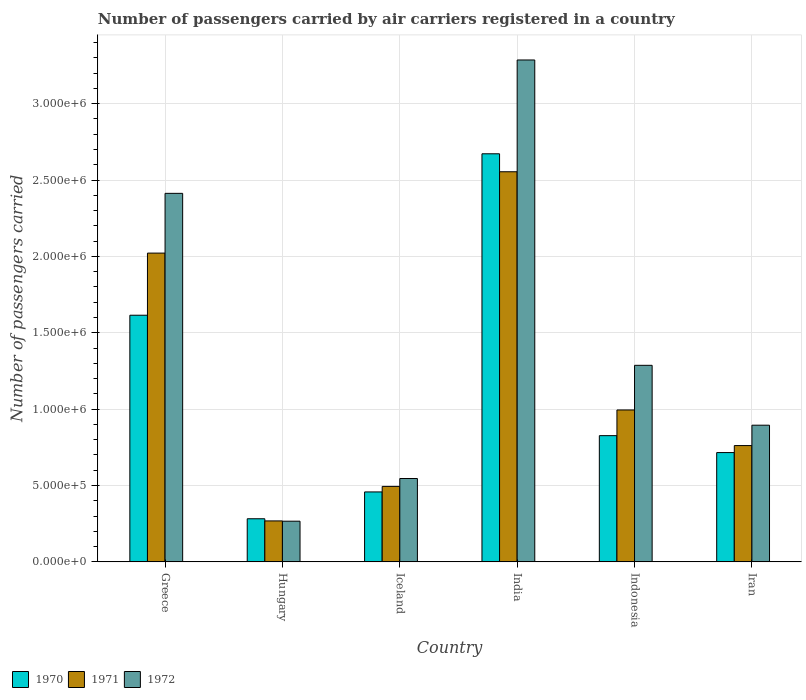How many different coloured bars are there?
Your answer should be compact. 3. How many groups of bars are there?
Keep it short and to the point. 6. Are the number of bars on each tick of the X-axis equal?
Offer a very short reply. Yes. What is the number of passengers carried by air carriers in 1971 in Hungary?
Give a very brief answer. 2.68e+05. Across all countries, what is the maximum number of passengers carried by air carriers in 1970?
Your answer should be very brief. 2.67e+06. Across all countries, what is the minimum number of passengers carried by air carriers in 1970?
Provide a short and direct response. 2.82e+05. In which country was the number of passengers carried by air carriers in 1971 minimum?
Your answer should be very brief. Hungary. What is the total number of passengers carried by air carriers in 1970 in the graph?
Provide a short and direct response. 6.57e+06. What is the difference between the number of passengers carried by air carriers in 1970 in Iceland and that in Indonesia?
Make the answer very short. -3.68e+05. What is the difference between the number of passengers carried by air carriers in 1971 in Greece and the number of passengers carried by air carriers in 1970 in Iran?
Provide a succinct answer. 1.31e+06. What is the average number of passengers carried by air carriers in 1971 per country?
Your answer should be compact. 1.18e+06. What is the difference between the number of passengers carried by air carriers of/in 1970 and number of passengers carried by air carriers of/in 1972 in India?
Your answer should be compact. -6.14e+05. In how many countries, is the number of passengers carried by air carriers in 1972 greater than 400000?
Provide a short and direct response. 5. What is the ratio of the number of passengers carried by air carriers in 1971 in Hungary to that in Iran?
Keep it short and to the point. 0.35. What is the difference between the highest and the second highest number of passengers carried by air carriers in 1972?
Give a very brief answer. 8.73e+05. What is the difference between the highest and the lowest number of passengers carried by air carriers in 1970?
Provide a succinct answer. 2.39e+06. What does the 2nd bar from the left in Iceland represents?
Offer a terse response. 1971. What does the 3rd bar from the right in Hungary represents?
Provide a succinct answer. 1970. Is it the case that in every country, the sum of the number of passengers carried by air carriers in 1972 and number of passengers carried by air carriers in 1971 is greater than the number of passengers carried by air carriers in 1970?
Your answer should be compact. Yes. Are the values on the major ticks of Y-axis written in scientific E-notation?
Provide a short and direct response. Yes. Does the graph contain any zero values?
Your answer should be compact. No. How many legend labels are there?
Provide a short and direct response. 3. What is the title of the graph?
Offer a very short reply. Number of passengers carried by air carriers registered in a country. Does "1964" appear as one of the legend labels in the graph?
Your answer should be compact. No. What is the label or title of the Y-axis?
Your response must be concise. Number of passengers carried. What is the Number of passengers carried in 1970 in Greece?
Provide a succinct answer. 1.61e+06. What is the Number of passengers carried of 1971 in Greece?
Your answer should be compact. 2.02e+06. What is the Number of passengers carried of 1972 in Greece?
Offer a very short reply. 2.41e+06. What is the Number of passengers carried in 1970 in Hungary?
Give a very brief answer. 2.82e+05. What is the Number of passengers carried of 1971 in Hungary?
Your answer should be compact. 2.68e+05. What is the Number of passengers carried in 1972 in Hungary?
Make the answer very short. 2.66e+05. What is the Number of passengers carried in 1970 in Iceland?
Offer a terse response. 4.58e+05. What is the Number of passengers carried in 1971 in Iceland?
Offer a terse response. 4.94e+05. What is the Number of passengers carried of 1972 in Iceland?
Ensure brevity in your answer.  5.46e+05. What is the Number of passengers carried in 1970 in India?
Your answer should be compact. 2.67e+06. What is the Number of passengers carried in 1971 in India?
Your answer should be very brief. 2.55e+06. What is the Number of passengers carried of 1972 in India?
Offer a terse response. 3.29e+06. What is the Number of passengers carried of 1970 in Indonesia?
Give a very brief answer. 8.26e+05. What is the Number of passengers carried of 1971 in Indonesia?
Ensure brevity in your answer.  9.94e+05. What is the Number of passengers carried in 1972 in Indonesia?
Keep it short and to the point. 1.29e+06. What is the Number of passengers carried in 1970 in Iran?
Keep it short and to the point. 7.16e+05. What is the Number of passengers carried of 1971 in Iran?
Offer a very short reply. 7.61e+05. What is the Number of passengers carried in 1972 in Iran?
Offer a terse response. 8.95e+05. Across all countries, what is the maximum Number of passengers carried in 1970?
Your answer should be compact. 2.67e+06. Across all countries, what is the maximum Number of passengers carried of 1971?
Ensure brevity in your answer.  2.55e+06. Across all countries, what is the maximum Number of passengers carried of 1972?
Your answer should be very brief. 3.29e+06. Across all countries, what is the minimum Number of passengers carried of 1970?
Give a very brief answer. 2.82e+05. Across all countries, what is the minimum Number of passengers carried in 1971?
Provide a succinct answer. 2.68e+05. Across all countries, what is the minimum Number of passengers carried of 1972?
Your response must be concise. 2.66e+05. What is the total Number of passengers carried in 1970 in the graph?
Offer a terse response. 6.57e+06. What is the total Number of passengers carried of 1971 in the graph?
Make the answer very short. 7.09e+06. What is the total Number of passengers carried of 1972 in the graph?
Provide a short and direct response. 8.69e+06. What is the difference between the Number of passengers carried in 1970 in Greece and that in Hungary?
Offer a very short reply. 1.33e+06. What is the difference between the Number of passengers carried in 1971 in Greece and that in Hungary?
Make the answer very short. 1.75e+06. What is the difference between the Number of passengers carried of 1972 in Greece and that in Hungary?
Give a very brief answer. 2.15e+06. What is the difference between the Number of passengers carried of 1970 in Greece and that in Iceland?
Provide a short and direct response. 1.16e+06. What is the difference between the Number of passengers carried of 1971 in Greece and that in Iceland?
Provide a short and direct response. 1.53e+06. What is the difference between the Number of passengers carried in 1972 in Greece and that in Iceland?
Make the answer very short. 1.87e+06. What is the difference between the Number of passengers carried in 1970 in Greece and that in India?
Ensure brevity in your answer.  -1.06e+06. What is the difference between the Number of passengers carried in 1971 in Greece and that in India?
Ensure brevity in your answer.  -5.33e+05. What is the difference between the Number of passengers carried in 1972 in Greece and that in India?
Give a very brief answer. -8.73e+05. What is the difference between the Number of passengers carried in 1970 in Greece and that in Indonesia?
Your response must be concise. 7.88e+05. What is the difference between the Number of passengers carried in 1971 in Greece and that in Indonesia?
Make the answer very short. 1.03e+06. What is the difference between the Number of passengers carried of 1972 in Greece and that in Indonesia?
Provide a succinct answer. 1.13e+06. What is the difference between the Number of passengers carried of 1970 in Greece and that in Iran?
Offer a terse response. 8.99e+05. What is the difference between the Number of passengers carried of 1971 in Greece and that in Iran?
Provide a succinct answer. 1.26e+06. What is the difference between the Number of passengers carried in 1972 in Greece and that in Iran?
Your response must be concise. 1.52e+06. What is the difference between the Number of passengers carried of 1970 in Hungary and that in Iceland?
Your answer should be very brief. -1.76e+05. What is the difference between the Number of passengers carried of 1971 in Hungary and that in Iceland?
Your answer should be very brief. -2.26e+05. What is the difference between the Number of passengers carried in 1972 in Hungary and that in Iceland?
Your response must be concise. -2.80e+05. What is the difference between the Number of passengers carried in 1970 in Hungary and that in India?
Offer a terse response. -2.39e+06. What is the difference between the Number of passengers carried in 1971 in Hungary and that in India?
Give a very brief answer. -2.29e+06. What is the difference between the Number of passengers carried of 1972 in Hungary and that in India?
Make the answer very short. -3.02e+06. What is the difference between the Number of passengers carried of 1970 in Hungary and that in Indonesia?
Ensure brevity in your answer.  -5.44e+05. What is the difference between the Number of passengers carried of 1971 in Hungary and that in Indonesia?
Provide a succinct answer. -7.26e+05. What is the difference between the Number of passengers carried in 1972 in Hungary and that in Indonesia?
Keep it short and to the point. -1.02e+06. What is the difference between the Number of passengers carried in 1970 in Hungary and that in Iran?
Offer a very short reply. -4.33e+05. What is the difference between the Number of passengers carried of 1971 in Hungary and that in Iran?
Provide a succinct answer. -4.93e+05. What is the difference between the Number of passengers carried of 1972 in Hungary and that in Iran?
Provide a short and direct response. -6.28e+05. What is the difference between the Number of passengers carried in 1970 in Iceland and that in India?
Make the answer very short. -2.21e+06. What is the difference between the Number of passengers carried in 1971 in Iceland and that in India?
Offer a very short reply. -2.06e+06. What is the difference between the Number of passengers carried of 1972 in Iceland and that in India?
Your response must be concise. -2.74e+06. What is the difference between the Number of passengers carried in 1970 in Iceland and that in Indonesia?
Make the answer very short. -3.68e+05. What is the difference between the Number of passengers carried of 1971 in Iceland and that in Indonesia?
Provide a short and direct response. -5.00e+05. What is the difference between the Number of passengers carried in 1972 in Iceland and that in Indonesia?
Your answer should be very brief. -7.41e+05. What is the difference between the Number of passengers carried in 1970 in Iceland and that in Iran?
Ensure brevity in your answer.  -2.58e+05. What is the difference between the Number of passengers carried of 1971 in Iceland and that in Iran?
Ensure brevity in your answer.  -2.67e+05. What is the difference between the Number of passengers carried of 1972 in Iceland and that in Iran?
Provide a short and direct response. -3.49e+05. What is the difference between the Number of passengers carried in 1970 in India and that in Indonesia?
Your answer should be very brief. 1.85e+06. What is the difference between the Number of passengers carried of 1971 in India and that in Indonesia?
Offer a terse response. 1.56e+06. What is the difference between the Number of passengers carried in 1972 in India and that in Indonesia?
Your response must be concise. 2.00e+06. What is the difference between the Number of passengers carried in 1970 in India and that in Iran?
Your answer should be compact. 1.96e+06. What is the difference between the Number of passengers carried of 1971 in India and that in Iran?
Your answer should be very brief. 1.79e+06. What is the difference between the Number of passengers carried in 1972 in India and that in Iran?
Keep it short and to the point. 2.39e+06. What is the difference between the Number of passengers carried in 1970 in Indonesia and that in Iran?
Offer a terse response. 1.11e+05. What is the difference between the Number of passengers carried in 1971 in Indonesia and that in Iran?
Your response must be concise. 2.33e+05. What is the difference between the Number of passengers carried in 1972 in Indonesia and that in Iran?
Keep it short and to the point. 3.92e+05. What is the difference between the Number of passengers carried in 1970 in Greece and the Number of passengers carried in 1971 in Hungary?
Make the answer very short. 1.35e+06. What is the difference between the Number of passengers carried of 1970 in Greece and the Number of passengers carried of 1972 in Hungary?
Your response must be concise. 1.35e+06. What is the difference between the Number of passengers carried of 1971 in Greece and the Number of passengers carried of 1972 in Hungary?
Ensure brevity in your answer.  1.76e+06. What is the difference between the Number of passengers carried in 1970 in Greece and the Number of passengers carried in 1971 in Iceland?
Provide a short and direct response. 1.12e+06. What is the difference between the Number of passengers carried of 1970 in Greece and the Number of passengers carried of 1972 in Iceland?
Your answer should be compact. 1.07e+06. What is the difference between the Number of passengers carried of 1971 in Greece and the Number of passengers carried of 1972 in Iceland?
Offer a very short reply. 1.48e+06. What is the difference between the Number of passengers carried of 1970 in Greece and the Number of passengers carried of 1971 in India?
Offer a terse response. -9.39e+05. What is the difference between the Number of passengers carried in 1970 in Greece and the Number of passengers carried in 1972 in India?
Your response must be concise. -1.67e+06. What is the difference between the Number of passengers carried in 1971 in Greece and the Number of passengers carried in 1972 in India?
Make the answer very short. -1.26e+06. What is the difference between the Number of passengers carried of 1970 in Greece and the Number of passengers carried of 1971 in Indonesia?
Keep it short and to the point. 6.20e+05. What is the difference between the Number of passengers carried of 1970 in Greece and the Number of passengers carried of 1972 in Indonesia?
Keep it short and to the point. 3.28e+05. What is the difference between the Number of passengers carried in 1971 in Greece and the Number of passengers carried in 1972 in Indonesia?
Provide a succinct answer. 7.35e+05. What is the difference between the Number of passengers carried in 1970 in Greece and the Number of passengers carried in 1971 in Iran?
Keep it short and to the point. 8.53e+05. What is the difference between the Number of passengers carried of 1970 in Greece and the Number of passengers carried of 1972 in Iran?
Keep it short and to the point. 7.20e+05. What is the difference between the Number of passengers carried of 1971 in Greece and the Number of passengers carried of 1972 in Iran?
Provide a short and direct response. 1.13e+06. What is the difference between the Number of passengers carried in 1970 in Hungary and the Number of passengers carried in 1971 in Iceland?
Provide a short and direct response. -2.12e+05. What is the difference between the Number of passengers carried in 1970 in Hungary and the Number of passengers carried in 1972 in Iceland?
Your answer should be very brief. -2.64e+05. What is the difference between the Number of passengers carried of 1971 in Hungary and the Number of passengers carried of 1972 in Iceland?
Provide a short and direct response. -2.78e+05. What is the difference between the Number of passengers carried in 1970 in Hungary and the Number of passengers carried in 1971 in India?
Make the answer very short. -2.27e+06. What is the difference between the Number of passengers carried of 1970 in Hungary and the Number of passengers carried of 1972 in India?
Keep it short and to the point. -3.00e+06. What is the difference between the Number of passengers carried in 1971 in Hungary and the Number of passengers carried in 1972 in India?
Ensure brevity in your answer.  -3.02e+06. What is the difference between the Number of passengers carried of 1970 in Hungary and the Number of passengers carried of 1971 in Indonesia?
Provide a succinct answer. -7.12e+05. What is the difference between the Number of passengers carried in 1970 in Hungary and the Number of passengers carried in 1972 in Indonesia?
Offer a terse response. -1.00e+06. What is the difference between the Number of passengers carried in 1971 in Hungary and the Number of passengers carried in 1972 in Indonesia?
Make the answer very short. -1.02e+06. What is the difference between the Number of passengers carried of 1970 in Hungary and the Number of passengers carried of 1971 in Iran?
Your response must be concise. -4.79e+05. What is the difference between the Number of passengers carried of 1970 in Hungary and the Number of passengers carried of 1972 in Iran?
Your answer should be very brief. -6.12e+05. What is the difference between the Number of passengers carried of 1971 in Hungary and the Number of passengers carried of 1972 in Iran?
Keep it short and to the point. -6.27e+05. What is the difference between the Number of passengers carried in 1970 in Iceland and the Number of passengers carried in 1971 in India?
Provide a succinct answer. -2.10e+06. What is the difference between the Number of passengers carried in 1970 in Iceland and the Number of passengers carried in 1972 in India?
Offer a terse response. -2.83e+06. What is the difference between the Number of passengers carried in 1971 in Iceland and the Number of passengers carried in 1972 in India?
Your answer should be compact. -2.79e+06. What is the difference between the Number of passengers carried in 1970 in Iceland and the Number of passengers carried in 1971 in Indonesia?
Your answer should be very brief. -5.37e+05. What is the difference between the Number of passengers carried of 1970 in Iceland and the Number of passengers carried of 1972 in Indonesia?
Provide a short and direct response. -8.29e+05. What is the difference between the Number of passengers carried of 1971 in Iceland and the Number of passengers carried of 1972 in Indonesia?
Provide a succinct answer. -7.93e+05. What is the difference between the Number of passengers carried in 1970 in Iceland and the Number of passengers carried in 1971 in Iran?
Offer a very short reply. -3.04e+05. What is the difference between the Number of passengers carried of 1970 in Iceland and the Number of passengers carried of 1972 in Iran?
Keep it short and to the point. -4.37e+05. What is the difference between the Number of passengers carried in 1971 in Iceland and the Number of passengers carried in 1972 in Iran?
Your answer should be compact. -4.01e+05. What is the difference between the Number of passengers carried in 1970 in India and the Number of passengers carried in 1971 in Indonesia?
Make the answer very short. 1.68e+06. What is the difference between the Number of passengers carried of 1970 in India and the Number of passengers carried of 1972 in Indonesia?
Your answer should be compact. 1.38e+06. What is the difference between the Number of passengers carried of 1971 in India and the Number of passengers carried of 1972 in Indonesia?
Offer a very short reply. 1.27e+06. What is the difference between the Number of passengers carried of 1970 in India and the Number of passengers carried of 1971 in Iran?
Your response must be concise. 1.91e+06. What is the difference between the Number of passengers carried in 1970 in India and the Number of passengers carried in 1972 in Iran?
Your answer should be very brief. 1.78e+06. What is the difference between the Number of passengers carried in 1971 in India and the Number of passengers carried in 1972 in Iran?
Provide a succinct answer. 1.66e+06. What is the difference between the Number of passengers carried of 1970 in Indonesia and the Number of passengers carried of 1971 in Iran?
Keep it short and to the point. 6.50e+04. What is the difference between the Number of passengers carried of 1970 in Indonesia and the Number of passengers carried of 1972 in Iran?
Keep it short and to the point. -6.84e+04. What is the difference between the Number of passengers carried in 1971 in Indonesia and the Number of passengers carried in 1972 in Iran?
Offer a terse response. 9.97e+04. What is the average Number of passengers carried of 1970 per country?
Ensure brevity in your answer.  1.09e+06. What is the average Number of passengers carried in 1971 per country?
Make the answer very short. 1.18e+06. What is the average Number of passengers carried in 1972 per country?
Offer a terse response. 1.45e+06. What is the difference between the Number of passengers carried of 1970 and Number of passengers carried of 1971 in Greece?
Provide a succinct answer. -4.07e+05. What is the difference between the Number of passengers carried in 1970 and Number of passengers carried in 1972 in Greece?
Offer a terse response. -7.98e+05. What is the difference between the Number of passengers carried of 1971 and Number of passengers carried of 1972 in Greece?
Provide a succinct answer. -3.91e+05. What is the difference between the Number of passengers carried in 1970 and Number of passengers carried in 1971 in Hungary?
Give a very brief answer. 1.41e+04. What is the difference between the Number of passengers carried in 1970 and Number of passengers carried in 1972 in Hungary?
Make the answer very short. 1.60e+04. What is the difference between the Number of passengers carried in 1971 and Number of passengers carried in 1972 in Hungary?
Provide a short and direct response. 1900. What is the difference between the Number of passengers carried of 1970 and Number of passengers carried of 1971 in Iceland?
Give a very brief answer. -3.62e+04. What is the difference between the Number of passengers carried of 1970 and Number of passengers carried of 1972 in Iceland?
Offer a terse response. -8.79e+04. What is the difference between the Number of passengers carried in 1971 and Number of passengers carried in 1972 in Iceland?
Your answer should be compact. -5.17e+04. What is the difference between the Number of passengers carried in 1970 and Number of passengers carried in 1971 in India?
Your answer should be compact. 1.18e+05. What is the difference between the Number of passengers carried in 1970 and Number of passengers carried in 1972 in India?
Your answer should be compact. -6.14e+05. What is the difference between the Number of passengers carried of 1971 and Number of passengers carried of 1972 in India?
Keep it short and to the point. -7.32e+05. What is the difference between the Number of passengers carried in 1970 and Number of passengers carried in 1971 in Indonesia?
Your answer should be compact. -1.68e+05. What is the difference between the Number of passengers carried in 1970 and Number of passengers carried in 1972 in Indonesia?
Give a very brief answer. -4.60e+05. What is the difference between the Number of passengers carried in 1971 and Number of passengers carried in 1972 in Indonesia?
Ensure brevity in your answer.  -2.92e+05. What is the difference between the Number of passengers carried in 1970 and Number of passengers carried in 1971 in Iran?
Your response must be concise. -4.58e+04. What is the difference between the Number of passengers carried of 1970 and Number of passengers carried of 1972 in Iran?
Offer a very short reply. -1.79e+05. What is the difference between the Number of passengers carried of 1971 and Number of passengers carried of 1972 in Iran?
Your answer should be compact. -1.33e+05. What is the ratio of the Number of passengers carried in 1970 in Greece to that in Hungary?
Make the answer very short. 5.72. What is the ratio of the Number of passengers carried of 1971 in Greece to that in Hungary?
Give a very brief answer. 7.54. What is the ratio of the Number of passengers carried in 1972 in Greece to that in Hungary?
Offer a very short reply. 9.06. What is the ratio of the Number of passengers carried of 1970 in Greece to that in Iceland?
Keep it short and to the point. 3.53. What is the ratio of the Number of passengers carried of 1971 in Greece to that in Iceland?
Provide a succinct answer. 4.09. What is the ratio of the Number of passengers carried of 1972 in Greece to that in Iceland?
Make the answer very short. 4.42. What is the ratio of the Number of passengers carried in 1970 in Greece to that in India?
Provide a short and direct response. 0.6. What is the ratio of the Number of passengers carried of 1971 in Greece to that in India?
Offer a terse response. 0.79. What is the ratio of the Number of passengers carried of 1972 in Greece to that in India?
Your response must be concise. 0.73. What is the ratio of the Number of passengers carried of 1970 in Greece to that in Indonesia?
Provide a succinct answer. 1.95. What is the ratio of the Number of passengers carried in 1971 in Greece to that in Indonesia?
Make the answer very short. 2.03. What is the ratio of the Number of passengers carried of 1972 in Greece to that in Indonesia?
Provide a short and direct response. 1.87. What is the ratio of the Number of passengers carried in 1970 in Greece to that in Iran?
Your answer should be compact. 2.26. What is the ratio of the Number of passengers carried of 1971 in Greece to that in Iran?
Make the answer very short. 2.65. What is the ratio of the Number of passengers carried of 1972 in Greece to that in Iran?
Offer a terse response. 2.7. What is the ratio of the Number of passengers carried in 1970 in Hungary to that in Iceland?
Your response must be concise. 0.62. What is the ratio of the Number of passengers carried of 1971 in Hungary to that in Iceland?
Your response must be concise. 0.54. What is the ratio of the Number of passengers carried of 1972 in Hungary to that in Iceland?
Offer a very short reply. 0.49. What is the ratio of the Number of passengers carried of 1970 in Hungary to that in India?
Your answer should be very brief. 0.11. What is the ratio of the Number of passengers carried of 1971 in Hungary to that in India?
Give a very brief answer. 0.1. What is the ratio of the Number of passengers carried of 1972 in Hungary to that in India?
Your answer should be compact. 0.08. What is the ratio of the Number of passengers carried of 1970 in Hungary to that in Indonesia?
Your response must be concise. 0.34. What is the ratio of the Number of passengers carried of 1971 in Hungary to that in Indonesia?
Your response must be concise. 0.27. What is the ratio of the Number of passengers carried of 1972 in Hungary to that in Indonesia?
Keep it short and to the point. 0.21. What is the ratio of the Number of passengers carried of 1970 in Hungary to that in Iran?
Keep it short and to the point. 0.39. What is the ratio of the Number of passengers carried of 1971 in Hungary to that in Iran?
Provide a short and direct response. 0.35. What is the ratio of the Number of passengers carried in 1972 in Hungary to that in Iran?
Ensure brevity in your answer.  0.3. What is the ratio of the Number of passengers carried in 1970 in Iceland to that in India?
Provide a short and direct response. 0.17. What is the ratio of the Number of passengers carried of 1971 in Iceland to that in India?
Offer a terse response. 0.19. What is the ratio of the Number of passengers carried of 1972 in Iceland to that in India?
Offer a terse response. 0.17. What is the ratio of the Number of passengers carried of 1970 in Iceland to that in Indonesia?
Your answer should be compact. 0.55. What is the ratio of the Number of passengers carried of 1971 in Iceland to that in Indonesia?
Offer a very short reply. 0.5. What is the ratio of the Number of passengers carried in 1972 in Iceland to that in Indonesia?
Give a very brief answer. 0.42. What is the ratio of the Number of passengers carried of 1970 in Iceland to that in Iran?
Keep it short and to the point. 0.64. What is the ratio of the Number of passengers carried of 1971 in Iceland to that in Iran?
Provide a short and direct response. 0.65. What is the ratio of the Number of passengers carried in 1972 in Iceland to that in Iran?
Ensure brevity in your answer.  0.61. What is the ratio of the Number of passengers carried in 1970 in India to that in Indonesia?
Make the answer very short. 3.23. What is the ratio of the Number of passengers carried in 1971 in India to that in Indonesia?
Offer a very short reply. 2.57. What is the ratio of the Number of passengers carried in 1972 in India to that in Indonesia?
Offer a very short reply. 2.55. What is the ratio of the Number of passengers carried of 1970 in India to that in Iran?
Provide a short and direct response. 3.73. What is the ratio of the Number of passengers carried in 1971 in India to that in Iran?
Your response must be concise. 3.35. What is the ratio of the Number of passengers carried in 1972 in India to that in Iran?
Provide a short and direct response. 3.67. What is the ratio of the Number of passengers carried in 1970 in Indonesia to that in Iran?
Ensure brevity in your answer.  1.15. What is the ratio of the Number of passengers carried of 1971 in Indonesia to that in Iran?
Your answer should be very brief. 1.31. What is the ratio of the Number of passengers carried of 1972 in Indonesia to that in Iran?
Provide a short and direct response. 1.44. What is the difference between the highest and the second highest Number of passengers carried in 1970?
Your answer should be compact. 1.06e+06. What is the difference between the highest and the second highest Number of passengers carried of 1971?
Provide a short and direct response. 5.33e+05. What is the difference between the highest and the second highest Number of passengers carried of 1972?
Offer a very short reply. 8.73e+05. What is the difference between the highest and the lowest Number of passengers carried in 1970?
Provide a short and direct response. 2.39e+06. What is the difference between the highest and the lowest Number of passengers carried of 1971?
Your answer should be compact. 2.29e+06. What is the difference between the highest and the lowest Number of passengers carried of 1972?
Your answer should be compact. 3.02e+06. 